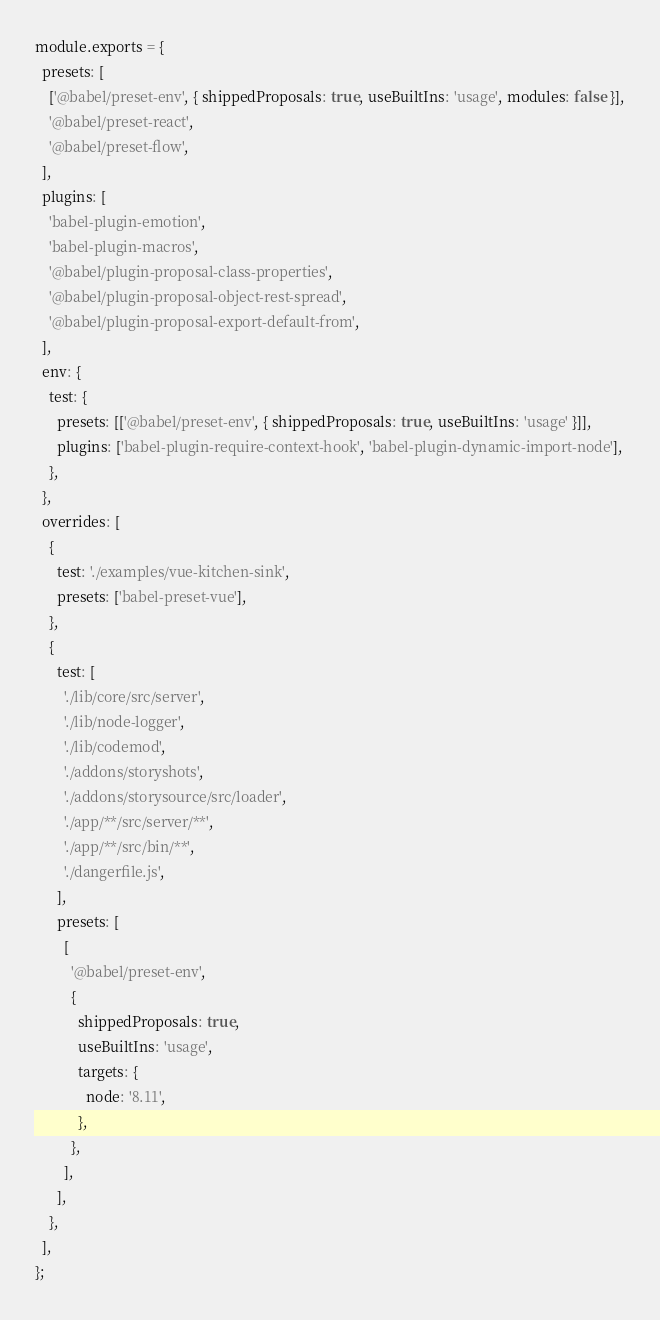Convert code to text. <code><loc_0><loc_0><loc_500><loc_500><_JavaScript_>module.exports = {
  presets: [
    ['@babel/preset-env', { shippedProposals: true, useBuiltIns: 'usage', modules: false }],
    '@babel/preset-react',
    '@babel/preset-flow',
  ],
  plugins: [
    'babel-plugin-emotion',
    'babel-plugin-macros',
    '@babel/plugin-proposal-class-properties',
    '@babel/plugin-proposal-object-rest-spread',
    '@babel/plugin-proposal-export-default-from',
  ],
  env: {
    test: {
      presets: [['@babel/preset-env', { shippedProposals: true, useBuiltIns: 'usage' }]],
      plugins: ['babel-plugin-require-context-hook', 'babel-plugin-dynamic-import-node'],
    },
  },
  overrides: [
    {
      test: './examples/vue-kitchen-sink',
      presets: ['babel-preset-vue'],
    },
    {
      test: [
        './lib/core/src/server',
        './lib/node-logger',
        './lib/codemod',
        './addons/storyshots',
        './addons/storysource/src/loader',
        './app/**/src/server/**',
        './app/**/src/bin/**',
        './dangerfile.js',
      ],
      presets: [
        [
          '@babel/preset-env',
          {
            shippedProposals: true,
            useBuiltIns: 'usage',
            targets: {
              node: '8.11',
            },
          },
        ],
      ],
    },
  ],
};
</code> 